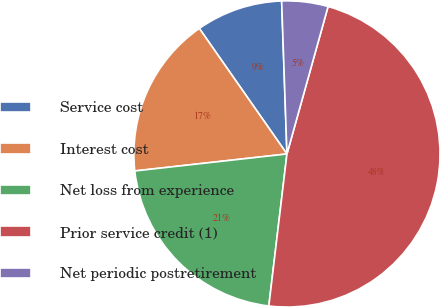Convert chart to OTSL. <chart><loc_0><loc_0><loc_500><loc_500><pie_chart><fcel>Service cost<fcel>Interest cost<fcel>Net loss from experience<fcel>Prior service credit (1)<fcel>Net periodic postretirement<nl><fcel>9.15%<fcel>17.07%<fcel>21.34%<fcel>47.56%<fcel>4.88%<nl></chart> 